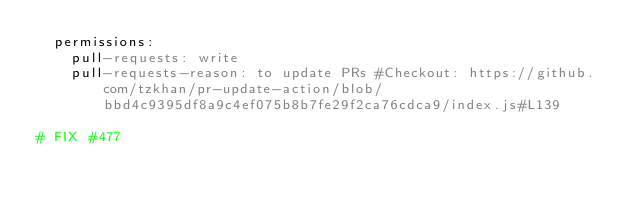<code> <loc_0><loc_0><loc_500><loc_500><_YAML_>  permissions:
    pull-requests: write
    pull-requests-reason: to update PRs #Checkout: https://github.com/tzkhan/pr-update-action/blob/bbd4c9395df8a9c4ef075b8b7fe29f2ca76cdca9/index.js#L139

# FIX #477</code> 